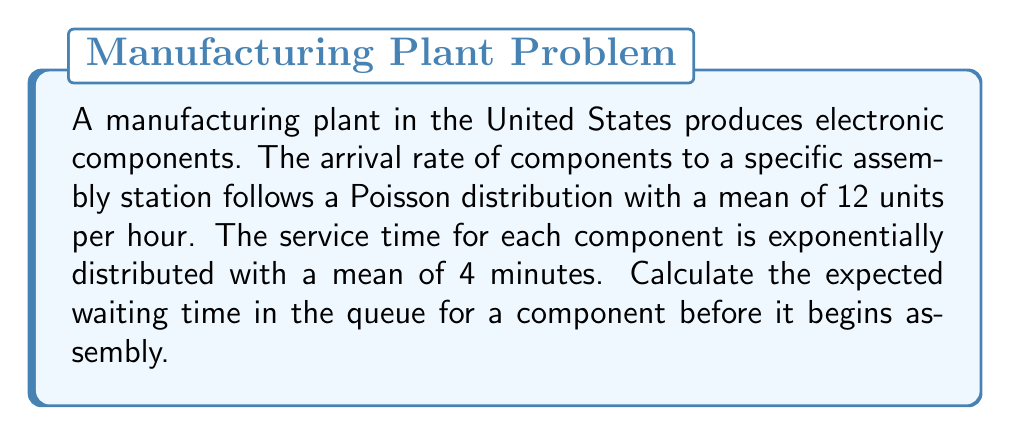Show me your answer to this math problem. To solve this problem, we'll use the M/M/1 queueing model and follow these steps:

1. Convert all rates to the same time unit (per hour):
   Arrival rate: $\lambda = 12$ units/hour
   Service rate: $\mu = 60/4 = 15$ units/hour (since 1 hour = 60 minutes)

2. Calculate the utilization factor $\rho$:
   $$\rho = \frac{\lambda}{\mu} = \frac{12}{15} = 0.8$$

3. Calculate the expected number of units in the queue $L_q$:
   $$L_q = \frac{\rho^2}{1-\rho} = \frac{0.8^2}{1-0.8} = \frac{0.64}{0.2} = 3.2$$

4. Apply Little's Law to find the expected waiting time in the queue $W_q$:
   $$W_q = \frac{L_q}{\lambda} = \frac{3.2}{12} = \frac{4}{15} \text{ hours}$$

5. Convert the result to minutes:
   $$W_q = \frac{4}{15} \times 60 = 16 \text{ minutes}$$

Therefore, the expected waiting time in the queue for a component before it begins assembly is 16 minutes.
Answer: 16 minutes 